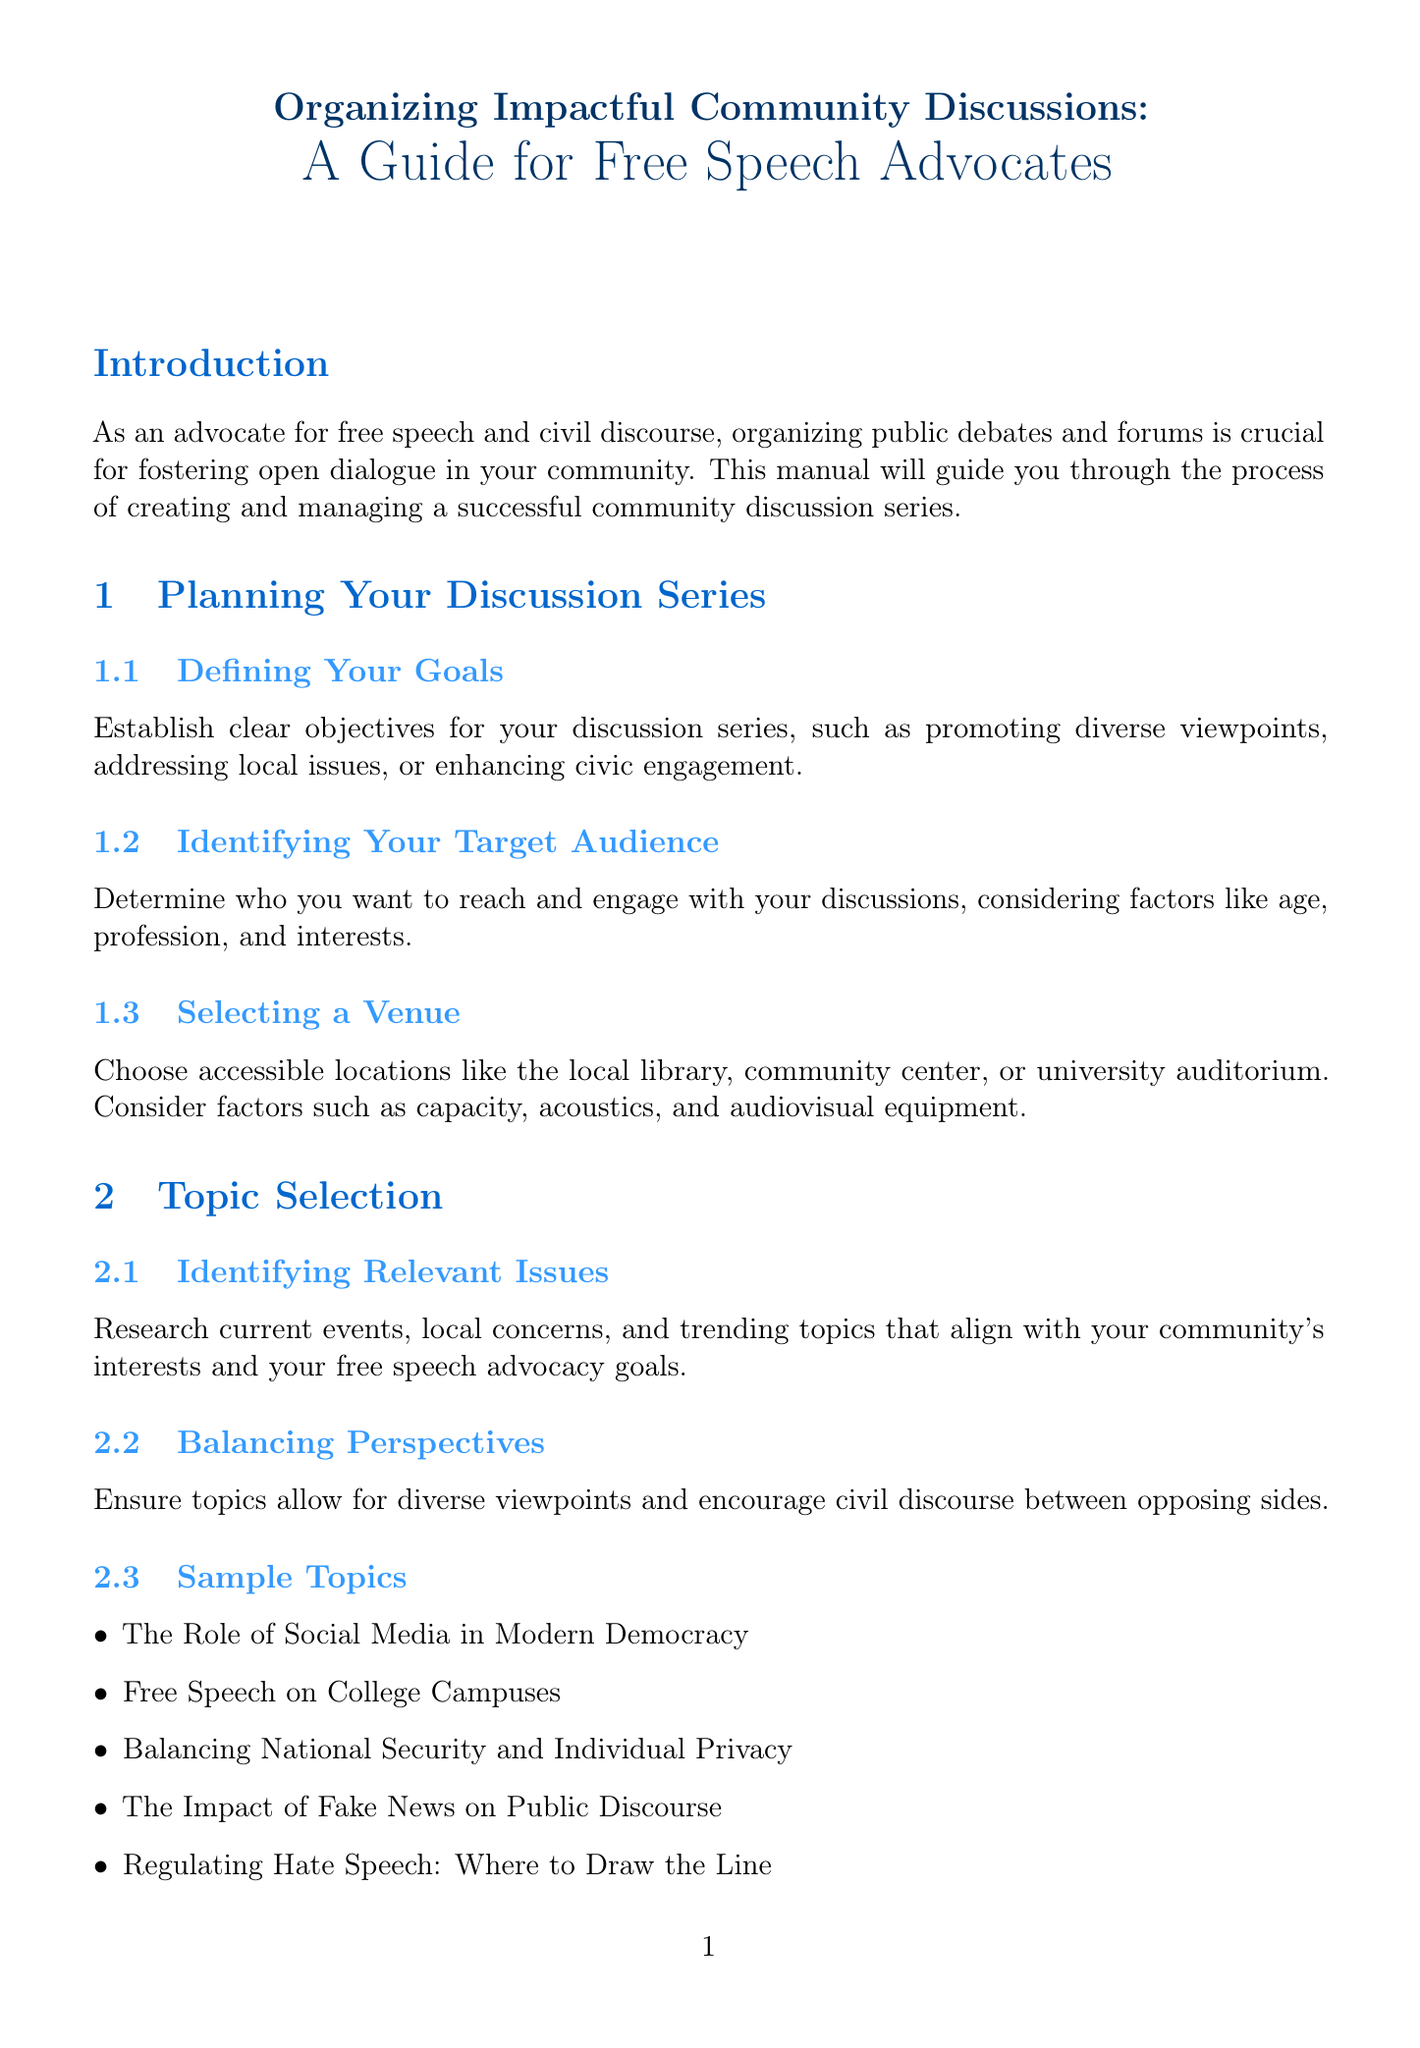What is the title of the manual? The title of the manual is clearly stated at the top of the document.
Answer: Organizing Impactful Community Discussions: A Guide for Free Speech Advocates What is one goal for the discussion series? One of the goals listed in the planning section is promoting diverse viewpoints.
Answer: Promoting diverse viewpoints What is a sample topic regarding free speech? The document provides a list of sample topics that include various aspects of free speech.
Answer: Free Speech on College Campuses Which format option is NOT mentioned in the manual? The list of format options includes various discussion styles, so any that are not listed are excluded.
Answer: N/A (for example: Roundtable Conversations is mentioned) What is a method for audience engagement mentioned in the document? Audience engagement strategies are discussed in detail under a specific section.
Answer: Live Polling How should speakers be selected? The manual suggests a guideline for choosing speakers and moderators, emphasizing diverse perspectives.
Answer: Diverse perspectives What tool can be used for collecting feedback? A specific tool is mentioned for distributing surveys to gather attendee opinions.
Answer: Google Forms Which organizations can be partnered with for promoting events? The document lists organizations that can enhance outreach and credibility, including a well-known civil rights group.
Answer: American Civil Liberties Union What is a suggested follow-up resource for attendees? The manual recommends providing attendees with additional materials related to the discussion topics.
Answer: Reading lists 